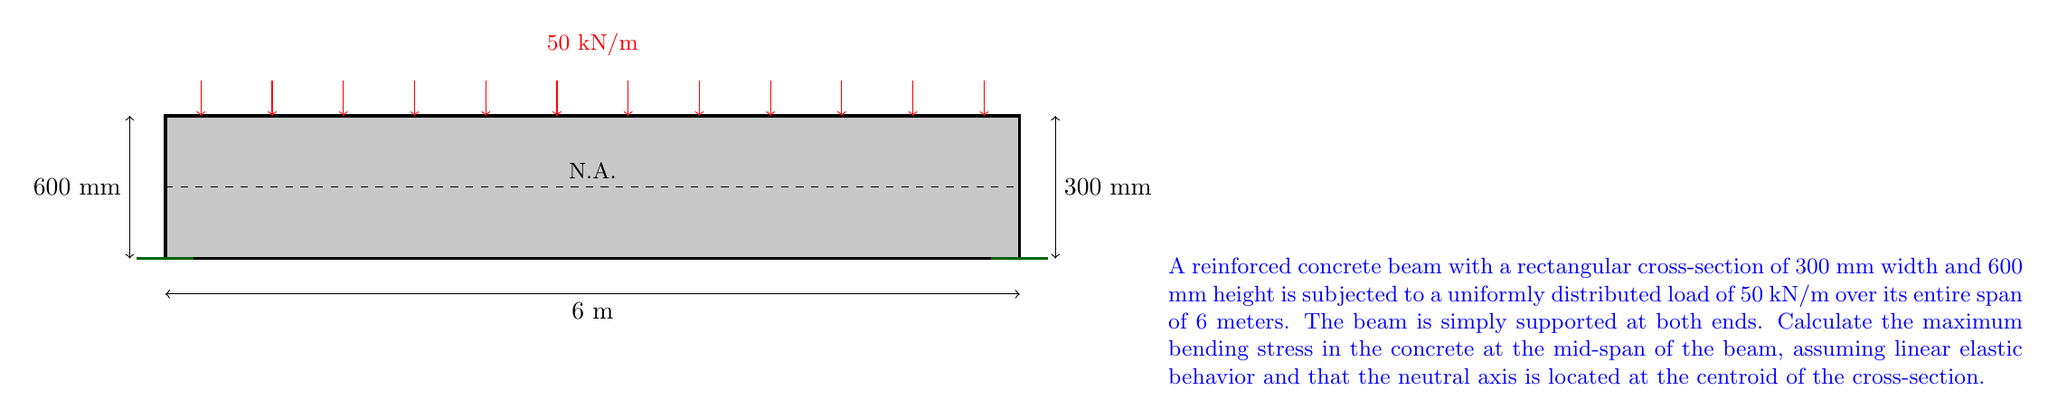Could you help me with this problem? To solve this problem, we'll follow these steps:

1) Calculate the maximum bending moment at mid-span:
   For a simply supported beam with uniformly distributed load:
   $$M_{max} = \frac{wL^2}{8}$$
   where $w$ is the distributed load and $L$ is the span length.
   
   $$M_{max} = \frac{50 \text{ kN/m} \times (6 \text{ m})^2}{8} = 225 \text{ kN·m}$$

2) Calculate the moment of inertia of the rectangular cross-section:
   $$I = \frac{bh^3}{12}$$
   where $b$ is the width and $h$ is the height of the cross-section.
   
   $$I = \frac{300 \text{ mm} \times (600 \text{ mm})^3}{12} = 5.4 \times 10^9 \text{ mm}^4$$

3) Calculate the distance from the neutral axis to the extreme fiber:
   Since the neutral axis is at the centroid, this distance is half the height.
   $$y = \frac{h}{2} = \frac{600 \text{ mm}}{2} = 300 \text{ mm}$$

4) Apply the flexure formula to calculate the maximum bending stress:
   $$\sigma_{max} = \frac{M_{max}y}{I}$$

   $$\sigma_{max} = \frac{225 \times 10^6 \text{ N·mm} \times 300 \text{ mm}}{5.4 \times 10^9 \text{ mm}^4} = 12.5 \text{ MPa}$$
Answer: 12.5 MPa 